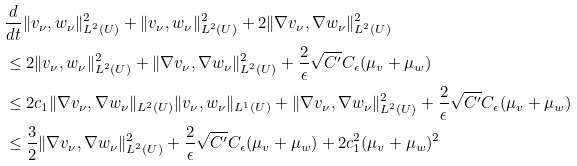<formula> <loc_0><loc_0><loc_500><loc_500>& \frac { d } { d t } \| v _ { \nu } , w _ { \nu } \| _ { L ^ { 2 } ( U ) } ^ { 2 } + \| v _ { \nu } , w _ { \nu } \| _ { L ^ { 2 } ( U ) } ^ { 2 } + 2 \| \nabla v _ { \nu } , \nabla w _ { \nu } \| _ { L ^ { 2 } ( U ) } ^ { 2 } \\ & \leq 2 \| v _ { \nu } , w _ { \nu } \| _ { L ^ { 2 } ( U ) } ^ { 2 } + \| \nabla v _ { \nu } , \nabla w _ { \nu } \| _ { L ^ { 2 } ( U ) } ^ { 2 } + \frac { 2 } { \epsilon } \sqrt { C ^ { \prime } } C _ { \epsilon } ( \mu _ { v } + \mu _ { w } ) \\ & \leq 2 c _ { 1 } \| \nabla v _ { \nu } , \nabla w _ { \nu } \| _ { L ^ { 2 } ( U ) } \| v _ { \nu } , w _ { \nu } \| _ { L ^ { 1 } ( U ) } + \| \nabla v _ { \nu } , \nabla w _ { \nu } \| _ { L ^ { 2 } ( U ) } ^ { 2 } + \frac { 2 } { \epsilon } \sqrt { C ^ { \prime } } C _ { \epsilon } ( \mu _ { v } + \mu _ { w } ) \\ & \leq \frac { 3 } { 2 } \| \nabla v _ { \nu } , \nabla w _ { \nu } \| _ { L ^ { 2 } ( U ) } ^ { 2 } + \frac { 2 } { \epsilon } \sqrt { C ^ { \prime } } C _ { \epsilon } ( \mu _ { v } + \mu _ { w } ) + 2 c _ { 1 } ^ { 2 } ( \mu _ { v } + \mu _ { w } ) ^ { 2 }</formula> 